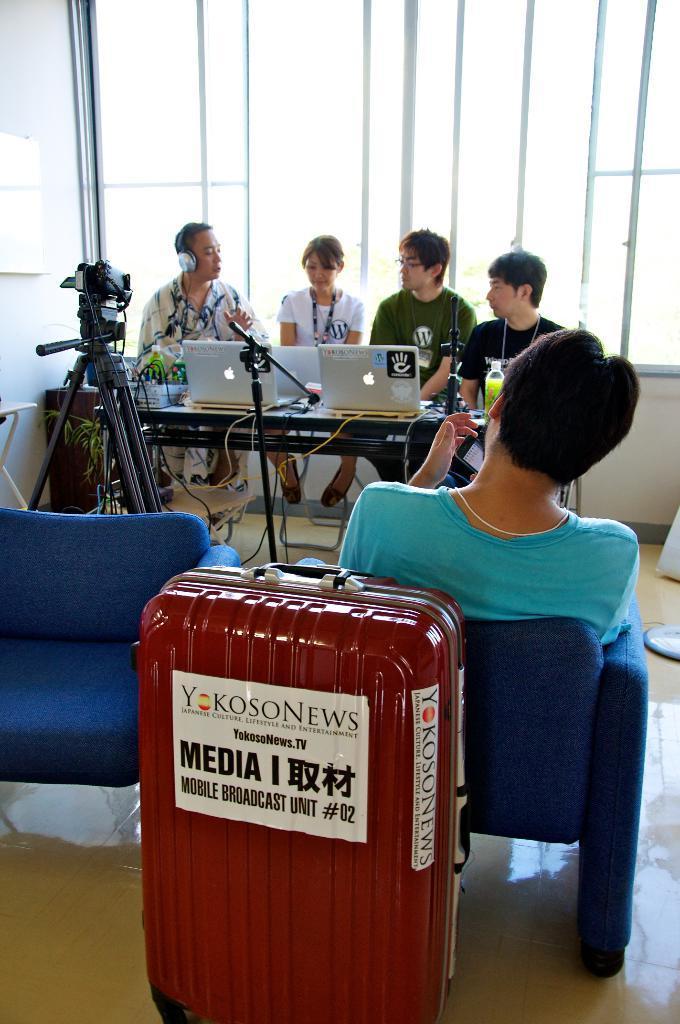Please provide a concise description of this image. Here are five people sitting on the chairs. This is a maroon color luggage bag with a paper attached to it. This looks like a video recorder on the tripod stand. This is a table with three laptops and some objects on it. At background this looks like a window. 